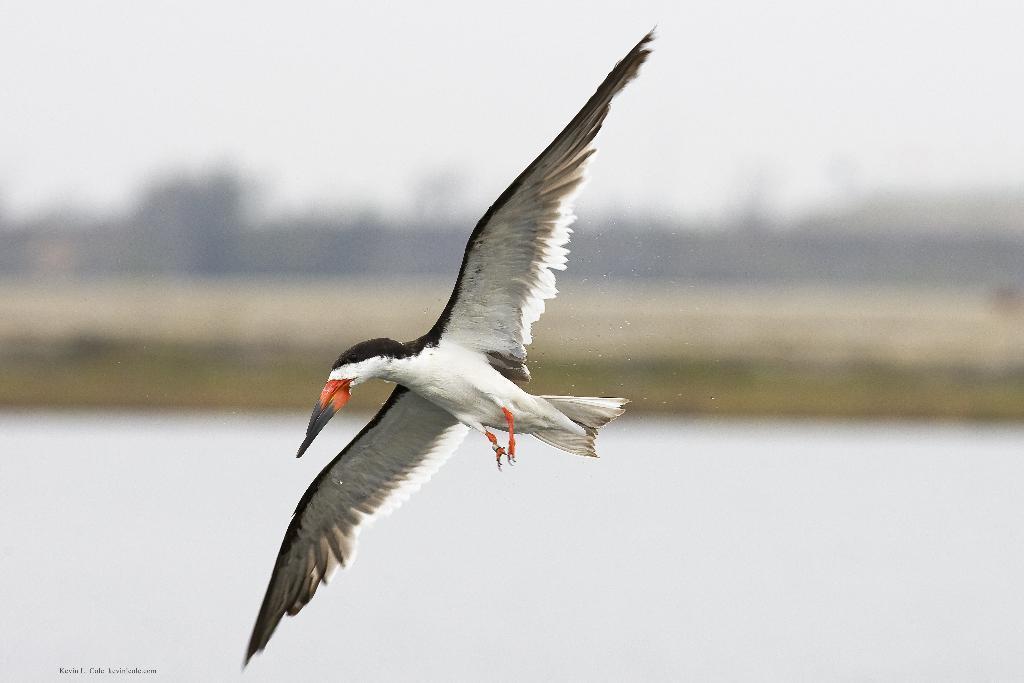How would you summarize this image in a sentence or two? This picture shows a bird flying it is white and black in color and we see water and trees and we see text at the bottom left corner. 